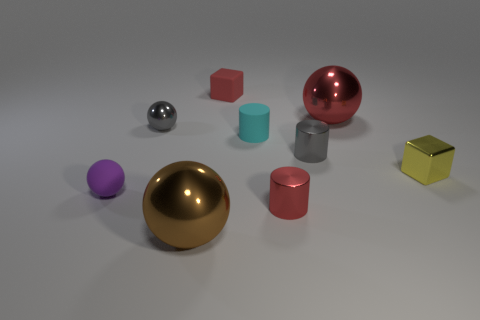There is a small red thing that is the same shape as the small yellow object; what is it made of?
Your response must be concise. Rubber. Are there any tiny objects on the right side of the tiny gray metallic object that is to the right of the small rubber cube that is left of the cyan object?
Provide a short and direct response. Yes. There is a red shiny thing that is behind the small purple ball; is it the same shape as the small metallic object to the left of the tiny cyan cylinder?
Provide a short and direct response. Yes. Is the number of metallic balls in front of the purple thing greater than the number of large gray matte spheres?
Keep it short and to the point. Yes. What number of things are either balls or red metal cylinders?
Your answer should be compact. 5. The rubber block is what color?
Make the answer very short. Red. How many other objects are there of the same color as the small shiny ball?
Ensure brevity in your answer.  1. Are there any purple rubber spheres behind the gray metallic cylinder?
Provide a short and direct response. No. There is a cylinder that is in front of the shiny cylinder that is behind the metallic cylinder that is in front of the tiny yellow metal object; what is its color?
Your answer should be compact. Red. How many cylinders are behind the tiny purple matte thing and in front of the small yellow metal thing?
Keep it short and to the point. 0. 